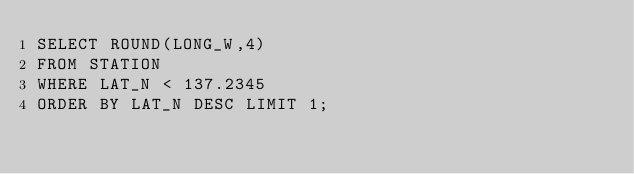Convert code to text. <code><loc_0><loc_0><loc_500><loc_500><_SQL_>SELECT ROUND(LONG_W,4)
FROM STATION
WHERE LAT_N < 137.2345
ORDER BY LAT_N DESC LIMIT 1;</code> 